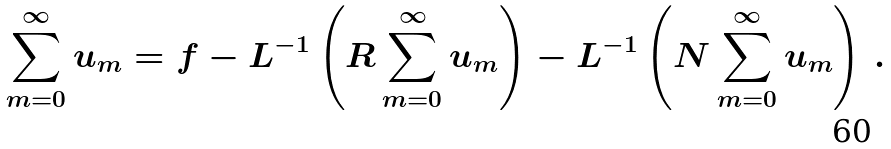<formula> <loc_0><loc_0><loc_500><loc_500>\sum _ { m = 0 } ^ { \infty } u _ { m } = f - L ^ { - 1 } \left ( R \sum _ { m = 0 } ^ { \infty } u _ { m } \right ) - L ^ { - 1 } \left ( N \sum _ { m = 0 } ^ { \infty } u _ { m } \right ) \, .</formula> 